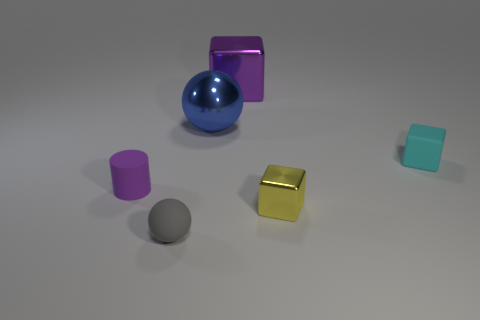What is the material of the block that is the same color as the small cylinder?
Your response must be concise. Metal. Is the number of tiny balls that are behind the large metallic block less than the number of objects that are in front of the tiny rubber cylinder?
Your response must be concise. Yes. There is a tiny matte thing to the left of the gray matte ball; is its color the same as the block that is behind the big ball?
Provide a succinct answer. Yes. Is there another tiny thing made of the same material as the small cyan thing?
Your answer should be very brief. Yes. What size is the rubber object right of the block that is behind the big blue object?
Your response must be concise. Small. Is the number of purple matte cylinders greater than the number of small things?
Ensure brevity in your answer.  No. There is a purple object that is on the right side of the blue metallic ball; is it the same size as the large ball?
Make the answer very short. Yes. What number of shiny things are the same color as the big metallic cube?
Your answer should be very brief. 0. Do the gray object and the yellow thing have the same shape?
Your response must be concise. No. Is there anything else that has the same size as the cyan matte block?
Keep it short and to the point. Yes. 